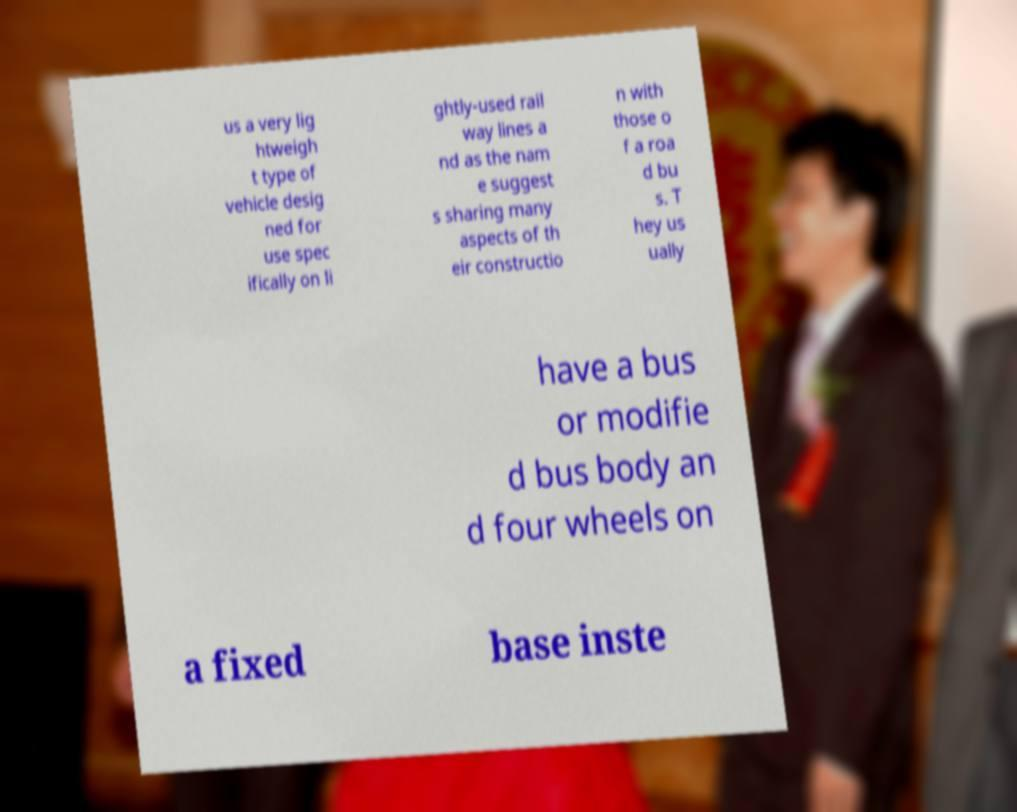I need the written content from this picture converted into text. Can you do that? us a very lig htweigh t type of vehicle desig ned for use spec ifically on li ghtly-used rail way lines a nd as the nam e suggest s sharing many aspects of th eir constructio n with those o f a roa d bu s. T hey us ually have a bus or modifie d bus body an d four wheels on a fixed base inste 